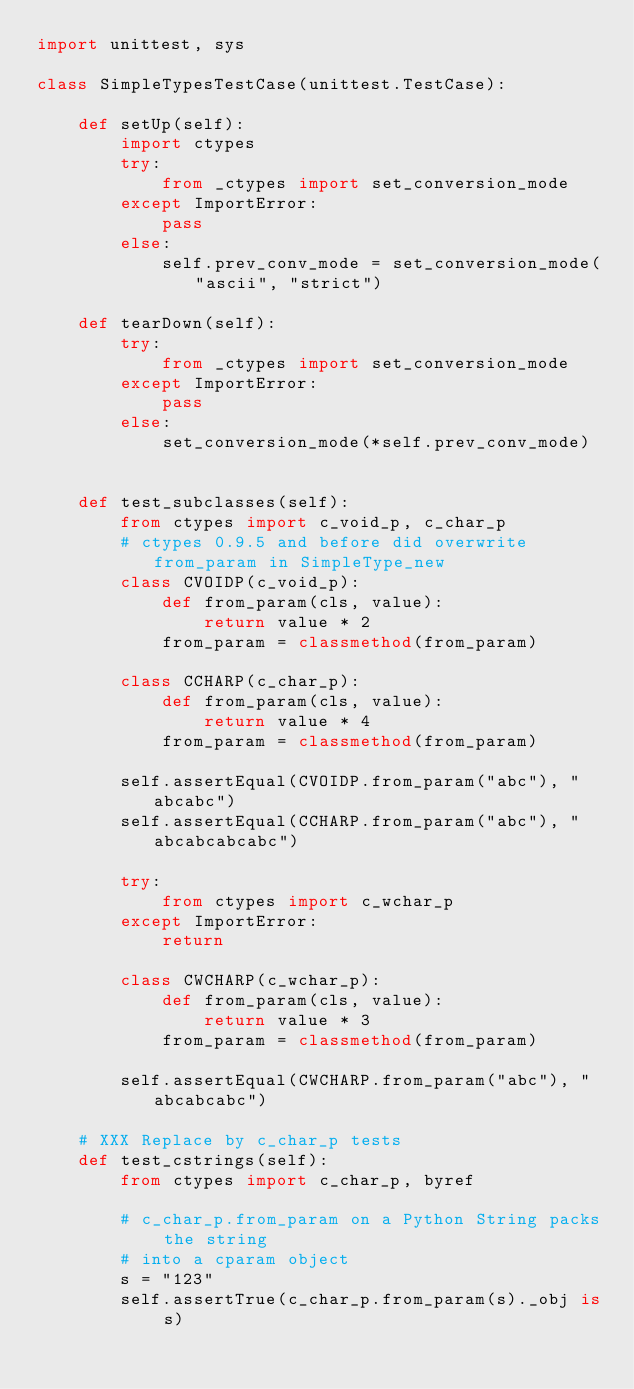<code> <loc_0><loc_0><loc_500><loc_500><_Python_>import unittest, sys

class SimpleTypesTestCase(unittest.TestCase):

    def setUp(self):
        import ctypes
        try:
            from _ctypes import set_conversion_mode
        except ImportError:
            pass
        else:
            self.prev_conv_mode = set_conversion_mode("ascii", "strict")

    def tearDown(self):
        try:
            from _ctypes import set_conversion_mode
        except ImportError:
            pass
        else:
            set_conversion_mode(*self.prev_conv_mode)


    def test_subclasses(self):
        from ctypes import c_void_p, c_char_p
        # ctypes 0.9.5 and before did overwrite from_param in SimpleType_new
        class CVOIDP(c_void_p):
            def from_param(cls, value):
                return value * 2
            from_param = classmethod(from_param)

        class CCHARP(c_char_p):
            def from_param(cls, value):
                return value * 4
            from_param = classmethod(from_param)

        self.assertEqual(CVOIDP.from_param("abc"), "abcabc")
        self.assertEqual(CCHARP.from_param("abc"), "abcabcabcabc")

        try:
            from ctypes import c_wchar_p
        except ImportError:
            return

        class CWCHARP(c_wchar_p):
            def from_param(cls, value):
                return value * 3
            from_param = classmethod(from_param)

        self.assertEqual(CWCHARP.from_param("abc"), "abcabcabc")

    # XXX Replace by c_char_p tests
    def test_cstrings(self):
        from ctypes import c_char_p, byref

        # c_char_p.from_param on a Python String packs the string
        # into a cparam object
        s = "123"
        self.assertTrue(c_char_p.from_param(s)._obj is s)
</code> 